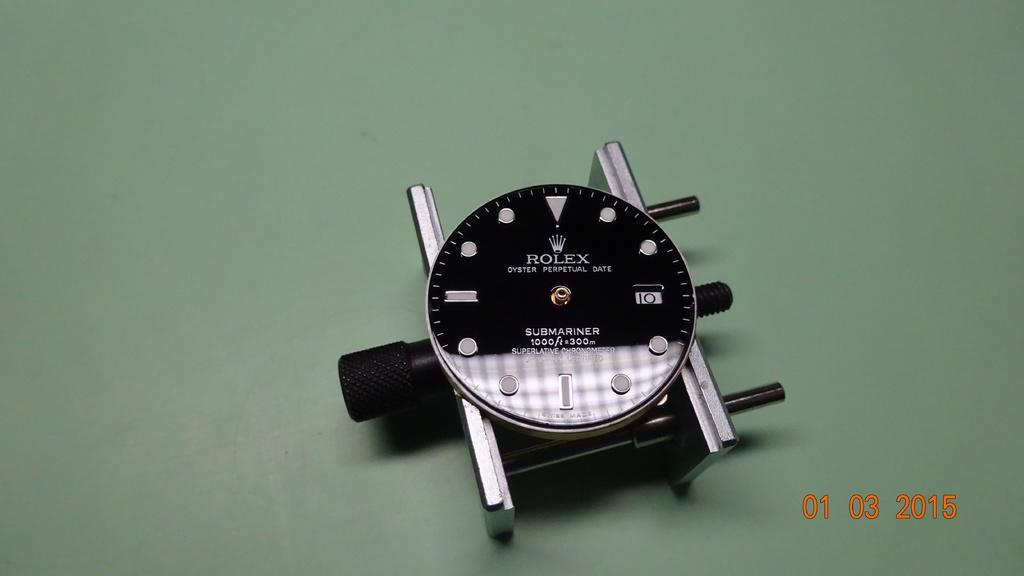What is the main object in the center of the image? There is a watch in the center of the image. What can be found on the watch? The watch has text on it. What color is the surface in the image? The surface in the image is green. What information is provided on the right side of the image? There are numbers representing a date on the right side of the image. What type of wool is used to make the brake in the image? There is no wool or brake present in the image; it features a watch and a green surface with numbers representing a date. 